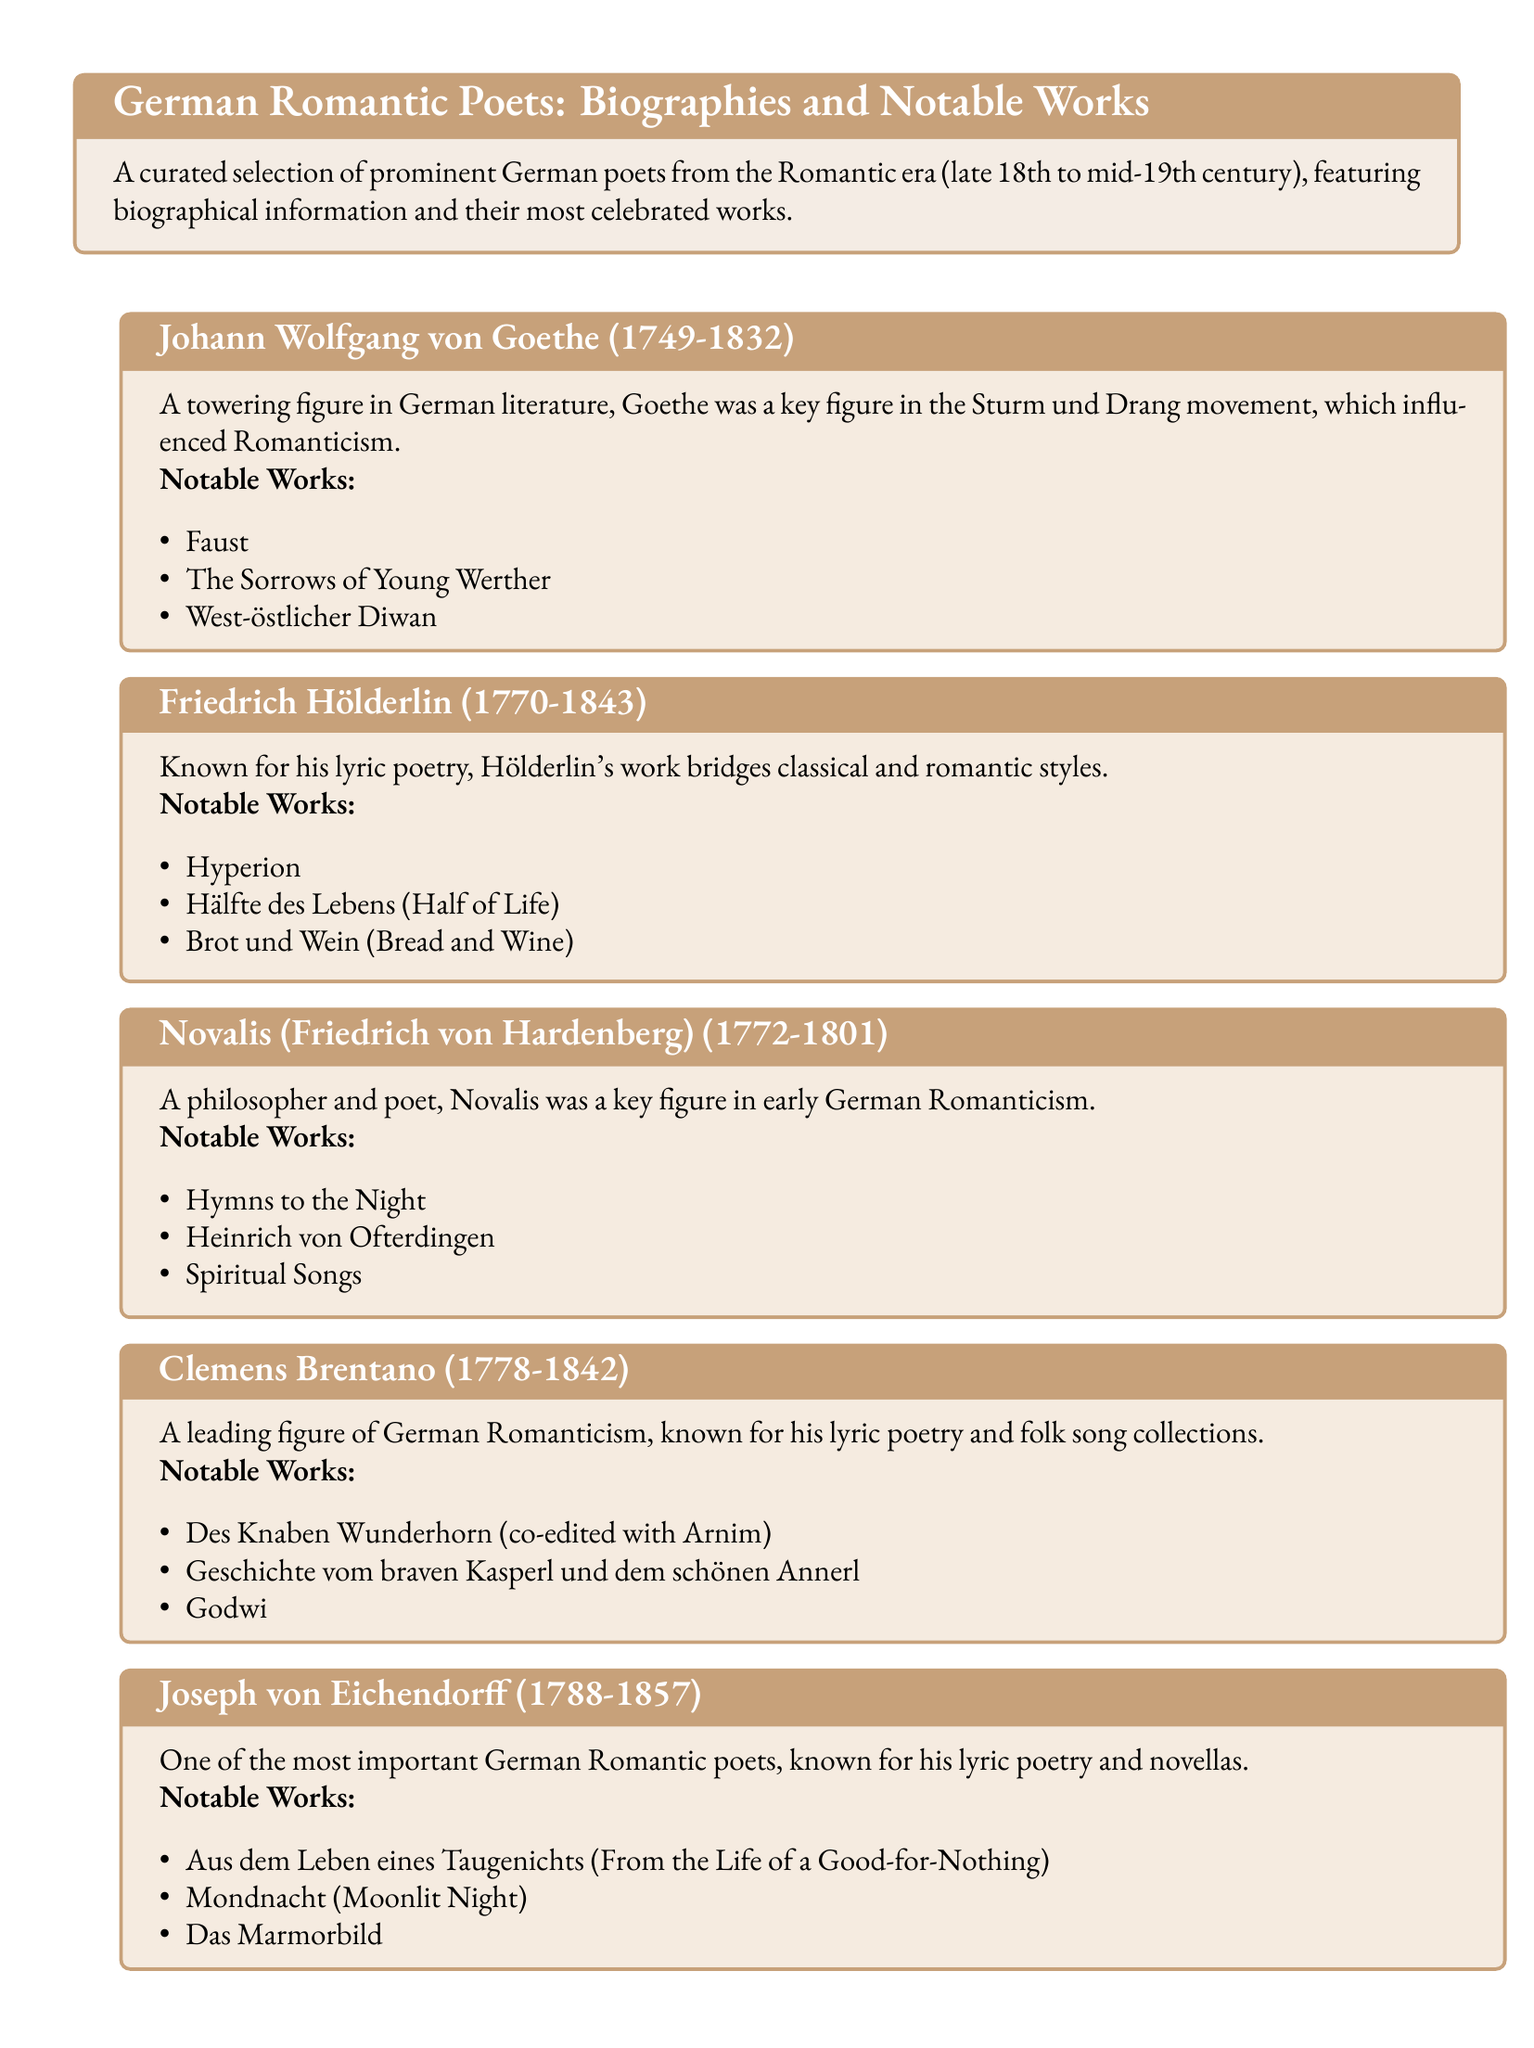What is the birth year of Johann Wolfgang von Goethe? The document lists Goethe's lifespan as 1749-1832, indicating he was born in 1749.
Answer: 1749 Which poet is known for the work "Hymns to the Night"? Novalis, mentioned in the document, is specifically noted for "Hymns to the Night."
Answer: Novalis How many notable works are listed for Joseph von Eichendorff? The document lists three notable works under Eichendorff's section, requiring counting to determine the number.
Answer: 3 What literary movement did Goethe influence? The document states that Goethe was a key figure in the Sturm und Drang movement, which influenced Romanticism.
Answer: Sturm und Drang Which poet's notable works include "Des Knaben Wunderhorn"? The document indicates that "Des Knaben Wunderhorn" is one of the notable works of Clemens Brentano.
Answer: Clemens Brentano Identify the poet who bridges classical and romantic styles. The document specifically notes that Friedrich Hölderlin is known for bridging these styles.
Answer: Friedrich Hölderlin What is the publication date range of the poets featured in the catalog? The document notes that the featured poets belong to the late 18th to mid-19th century, providing a specific time frame.
Answer: Late 18th to mid-19th century Which poet was born in 1788? According to the document, Joseph von Eichendorff was born in 1788.
Answer: Joseph von Eichendorff 